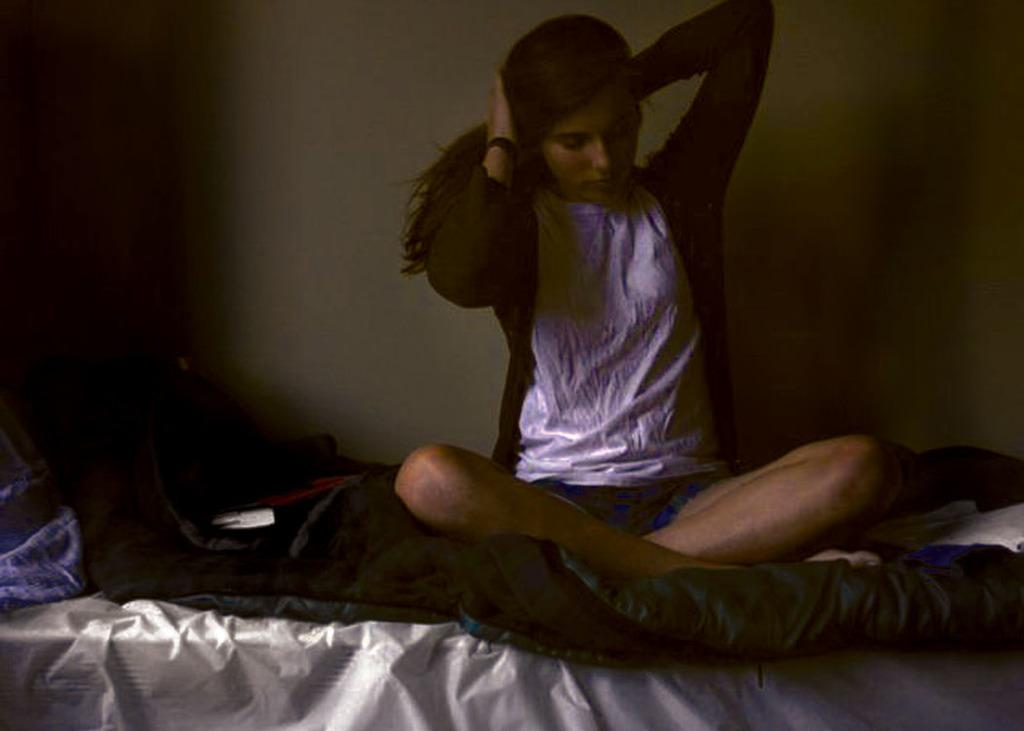Who is present in the image? There is a woman in the image. What is the woman doing in the image? The woman is sitting on a bed. What is the woman wearing in the image? The woman is wearing a white t-shirt. What color is the wall in the background of the image? There is a green-colored wall in the background. What is the color of the cloth at the bottom of the image? There is a white-colored cloth at the bottom of the image. What type of alley can be seen in the image? There is no alley present in the image. What kind of art is displayed on the wall in the image? There is no art displayed on the wall in the image; it is a plain green-colored wall. 